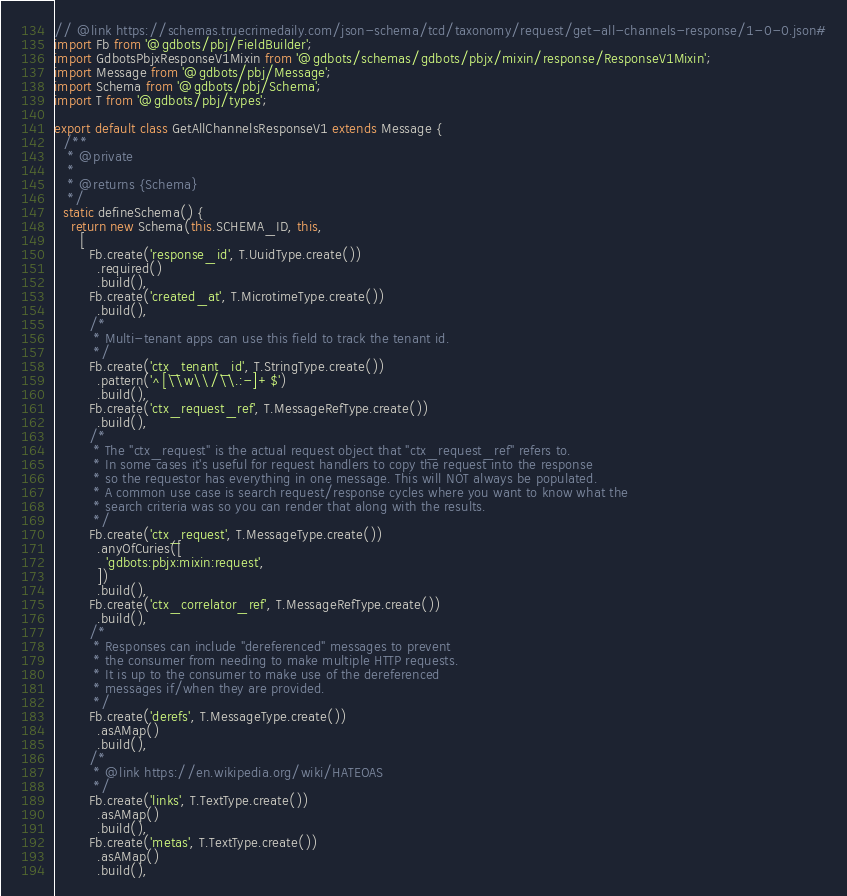Convert code to text. <code><loc_0><loc_0><loc_500><loc_500><_JavaScript_>// @link https://schemas.truecrimedaily.com/json-schema/tcd/taxonomy/request/get-all-channels-response/1-0-0.json#
import Fb from '@gdbots/pbj/FieldBuilder';
import GdbotsPbjxResponseV1Mixin from '@gdbots/schemas/gdbots/pbjx/mixin/response/ResponseV1Mixin';
import Message from '@gdbots/pbj/Message';
import Schema from '@gdbots/pbj/Schema';
import T from '@gdbots/pbj/types';

export default class GetAllChannelsResponseV1 extends Message {
  /**
   * @private
   *
   * @returns {Schema}
   */
  static defineSchema() {
    return new Schema(this.SCHEMA_ID, this,
      [
        Fb.create('response_id', T.UuidType.create())
          .required()
          .build(),
        Fb.create('created_at', T.MicrotimeType.create())
          .build(),
        /*
         * Multi-tenant apps can use this field to track the tenant id.
         */
        Fb.create('ctx_tenant_id', T.StringType.create())
          .pattern('^[\\w\\/\\.:-]+$')
          .build(),
        Fb.create('ctx_request_ref', T.MessageRefType.create())
          .build(),
        /*
         * The "ctx_request" is the actual request object that "ctx_request_ref" refers to.
         * In some cases it's useful for request handlers to copy the request into the response
         * so the requestor has everything in one message. This will NOT always be populated.
         * A common use case is search request/response cycles where you want to know what the
         * search criteria was so you can render that along with the results.
         */
        Fb.create('ctx_request', T.MessageType.create())
          .anyOfCuries([
            'gdbots:pbjx:mixin:request',
          ])
          .build(),
        Fb.create('ctx_correlator_ref', T.MessageRefType.create())
          .build(),
        /*
         * Responses can include "dereferenced" messages to prevent
         * the consumer from needing to make multiple HTTP requests.
         * It is up to the consumer to make use of the dereferenced
         * messages if/when they are provided.
         */
        Fb.create('derefs', T.MessageType.create())
          .asAMap()
          .build(),
        /*
         * @link https://en.wikipedia.org/wiki/HATEOAS
         */
        Fb.create('links', T.TextType.create())
          .asAMap()
          .build(),
        Fb.create('metas', T.TextType.create())
          .asAMap()
          .build(),</code> 